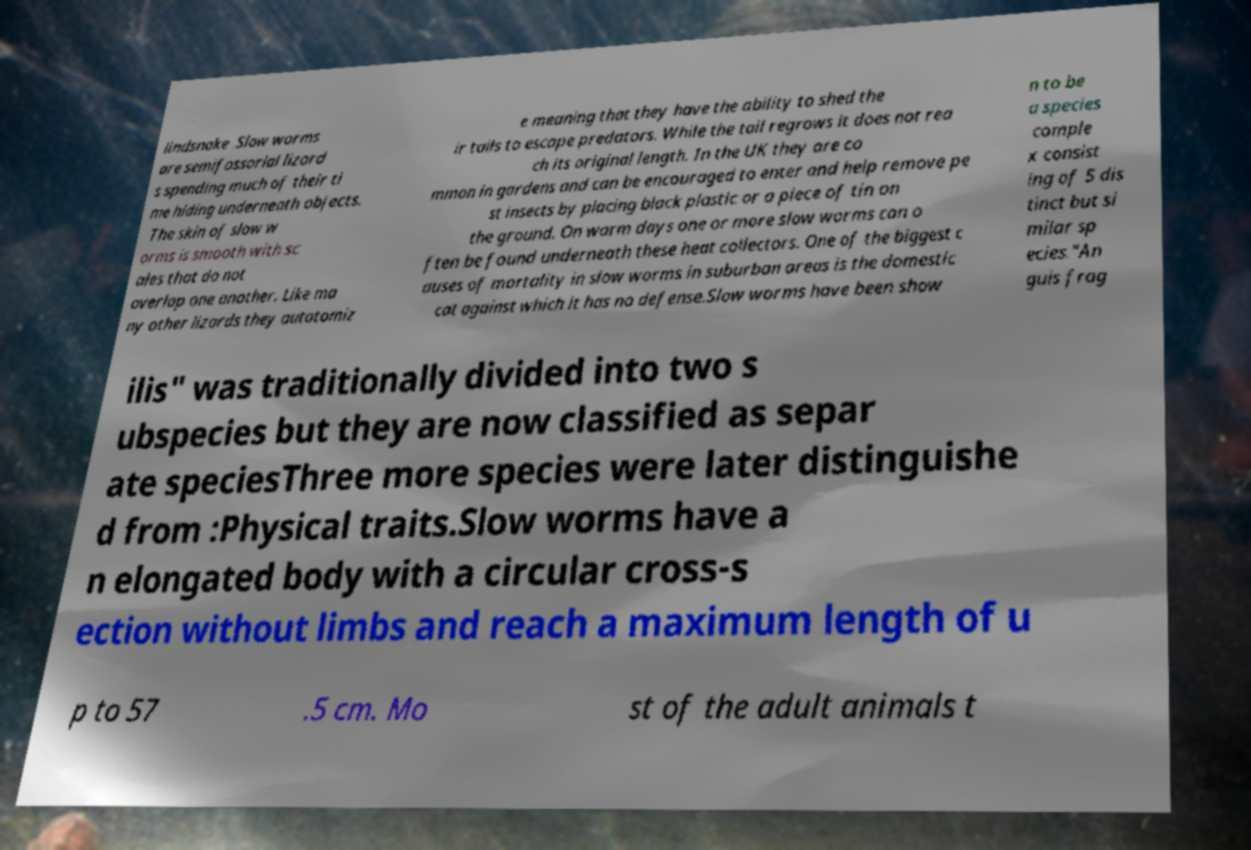Could you assist in decoding the text presented in this image and type it out clearly? lindsnake .Slow worms are semifossorial lizard s spending much of their ti me hiding underneath objects. The skin of slow w orms is smooth with sc ales that do not overlap one another. Like ma ny other lizards they autotomiz e meaning that they have the ability to shed the ir tails to escape predators. While the tail regrows it does not rea ch its original length. In the UK they are co mmon in gardens and can be encouraged to enter and help remove pe st insects by placing black plastic or a piece of tin on the ground. On warm days one or more slow worms can o ften be found underneath these heat collectors. One of the biggest c auses of mortality in slow worms in suburban areas is the domestic cat against which it has no defense.Slow worms have been show n to be a species comple x consist ing of 5 dis tinct but si milar sp ecies."An guis frag ilis" was traditionally divided into two s ubspecies but they are now classified as separ ate speciesThree more species were later distinguishe d from :Physical traits.Slow worms have a n elongated body with a circular cross-s ection without limbs and reach a maximum length of u p to 57 .5 cm. Mo st of the adult animals t 